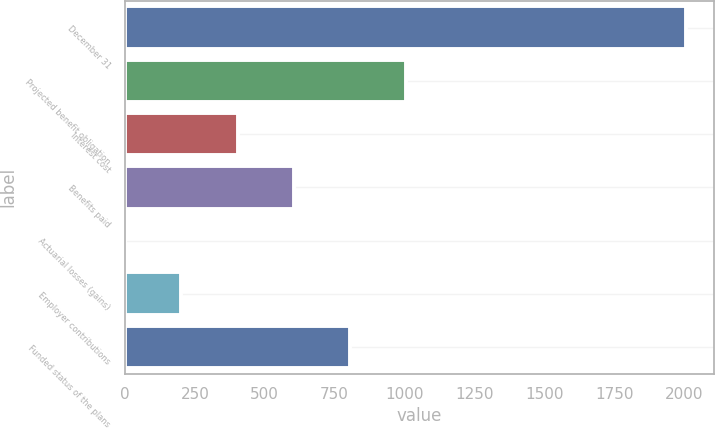Convert chart to OTSL. <chart><loc_0><loc_0><loc_500><loc_500><bar_chart><fcel>December 31<fcel>Projected benefit obligation<fcel>Interest cost<fcel>Benefits paid<fcel>Actuarial losses (gains)<fcel>Employer contributions<fcel>Funded status of the plans<nl><fcel>2008<fcel>1004.65<fcel>402.64<fcel>603.31<fcel>1.3<fcel>201.97<fcel>803.98<nl></chart> 